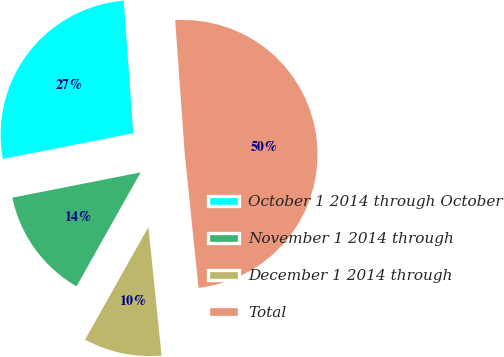Convert chart to OTSL. <chart><loc_0><loc_0><loc_500><loc_500><pie_chart><fcel>October 1 2014 through October<fcel>November 1 2014 through<fcel>December 1 2014 through<fcel>Total<nl><fcel>26.95%<fcel>13.75%<fcel>9.78%<fcel>49.51%<nl></chart> 